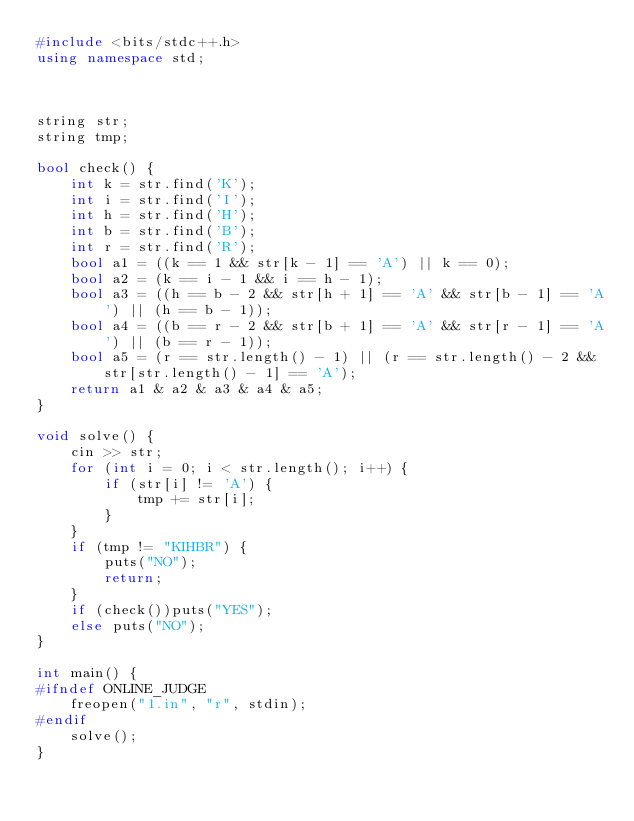<code> <loc_0><loc_0><loc_500><loc_500><_C++_>#include <bits/stdc++.h>
using namespace std;



string str;
string tmp;

bool check() {
	int k = str.find('K');
	int i = str.find('I');
	int h = str.find('H');
	int b = str.find('B');
	int r = str.find('R');
	bool a1 = ((k == 1 && str[k - 1] == 'A') || k == 0);
	bool a2 = (k == i - 1 && i == h - 1);
	bool a3 = ((h == b - 2 && str[h + 1] == 'A' && str[b - 1] == 'A') || (h == b - 1));
	bool a4 = ((b == r - 2 && str[b + 1] == 'A' && str[r - 1] == 'A') || (b == r - 1));
	bool a5 = (r == str.length() - 1) || (r == str.length() - 2 && str[str.length() - 1] == 'A');
	return a1 & a2 & a3 & a4 & a5;
}

void solve() {
	cin >> str;
	for (int i = 0; i < str.length(); i++) {
		if (str[i] != 'A') {
			tmp += str[i];
		}
	}
	if (tmp != "KIHBR") {
		puts("NO");
		return;
	}
	if (check())puts("YES");
	else puts("NO");
}

int main() {
#ifndef ONLINE_JUDGE
	freopen("1.in", "r", stdin);
#endif
	solve();
}</code> 